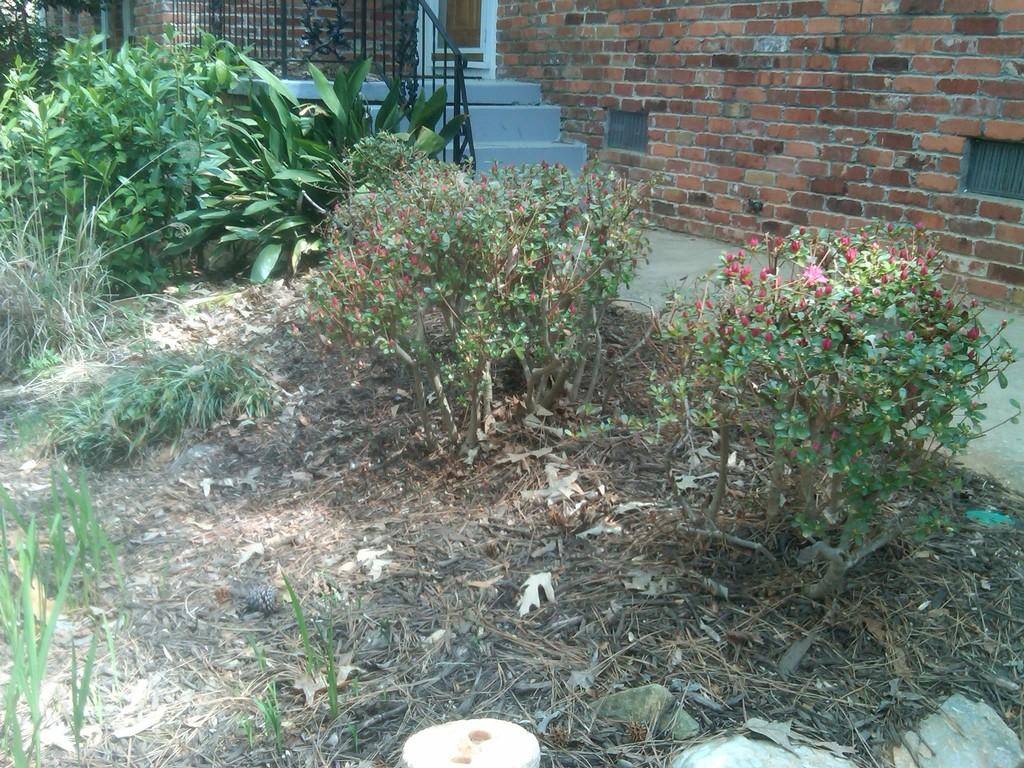What type of structure can be seen in the image? There is a wall with a door in the image. What architectural feature is present in the image? There are stairs in the image. What safety feature is included in the image? There is a railing in the image. What type of surface is visible in the image? There is a path in the image. What is the ground like in the image? Dry leaves are present on the ground. What type of vegetation is visible in the image? There are plants with flowers in the image. What type of grass is visible in the image? Grass is visible in the image. What type of treatment is being administered to the plants in the image? There is no indication in the image that any treatment is being administered to the plants. How does the rainstorm affect the visibility of the path in the image? There is no rainstorm present in the image, so its effect on the visibility of the path cannot be determined. 